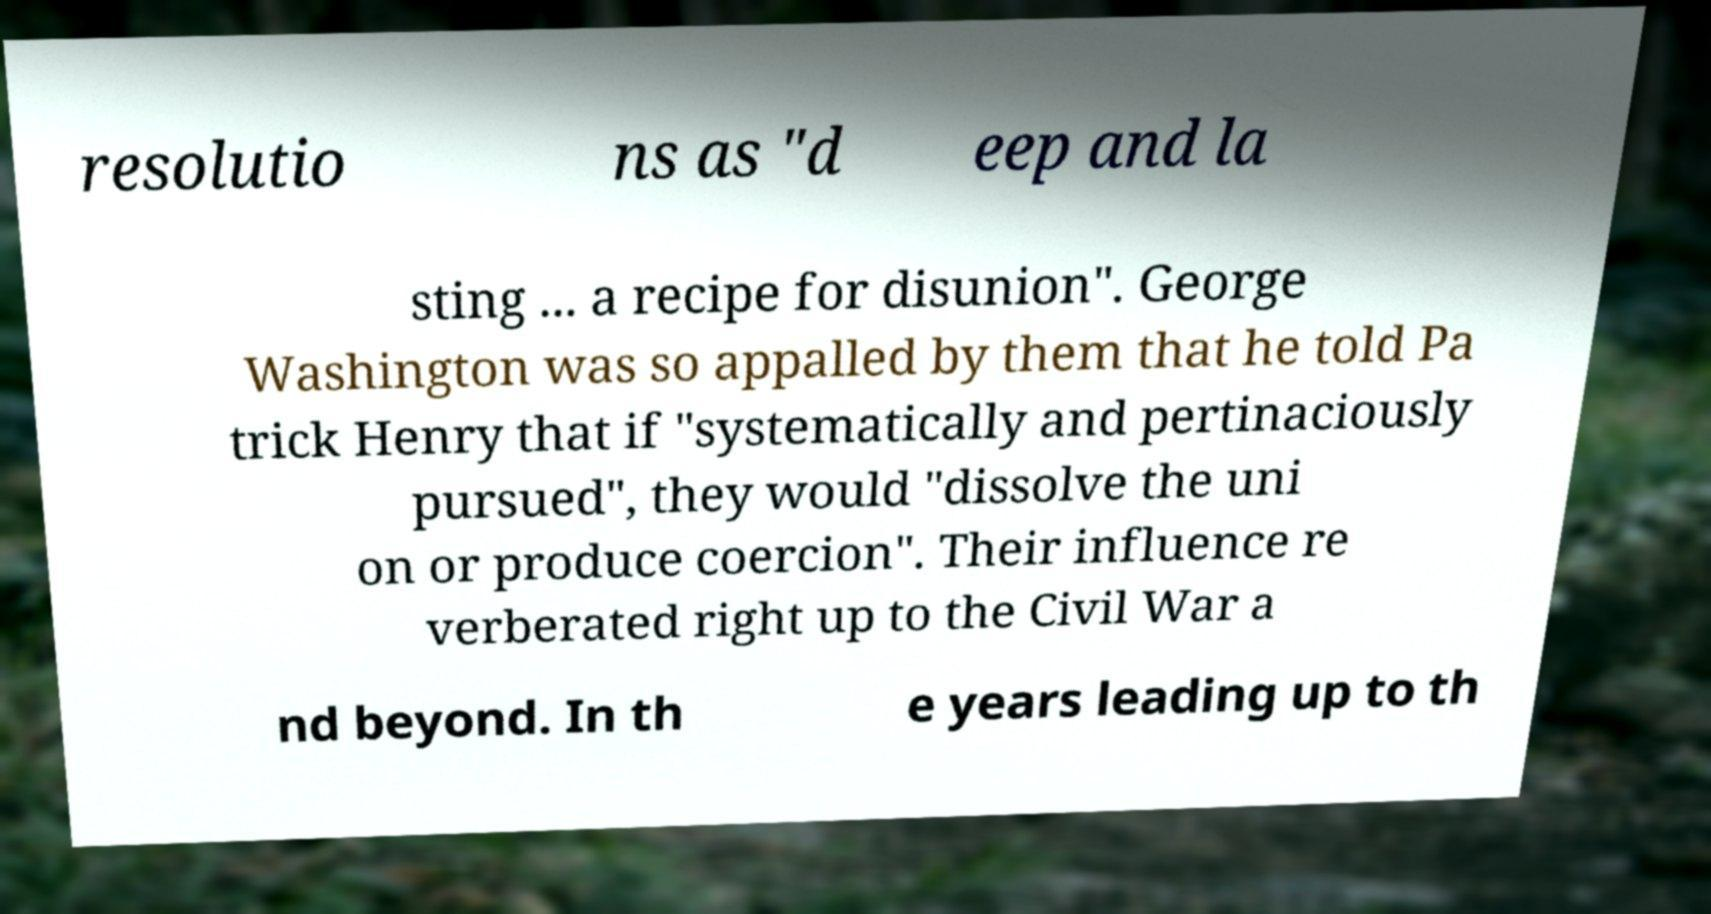Could you extract and type out the text from this image? resolutio ns as "d eep and la sting ... a recipe for disunion". George Washington was so appalled by them that he told Pa trick Henry that if "systematically and pertinaciously pursued", they would "dissolve the uni on or produce coercion". Their influence re verberated right up to the Civil War a nd beyond. In th e years leading up to th 